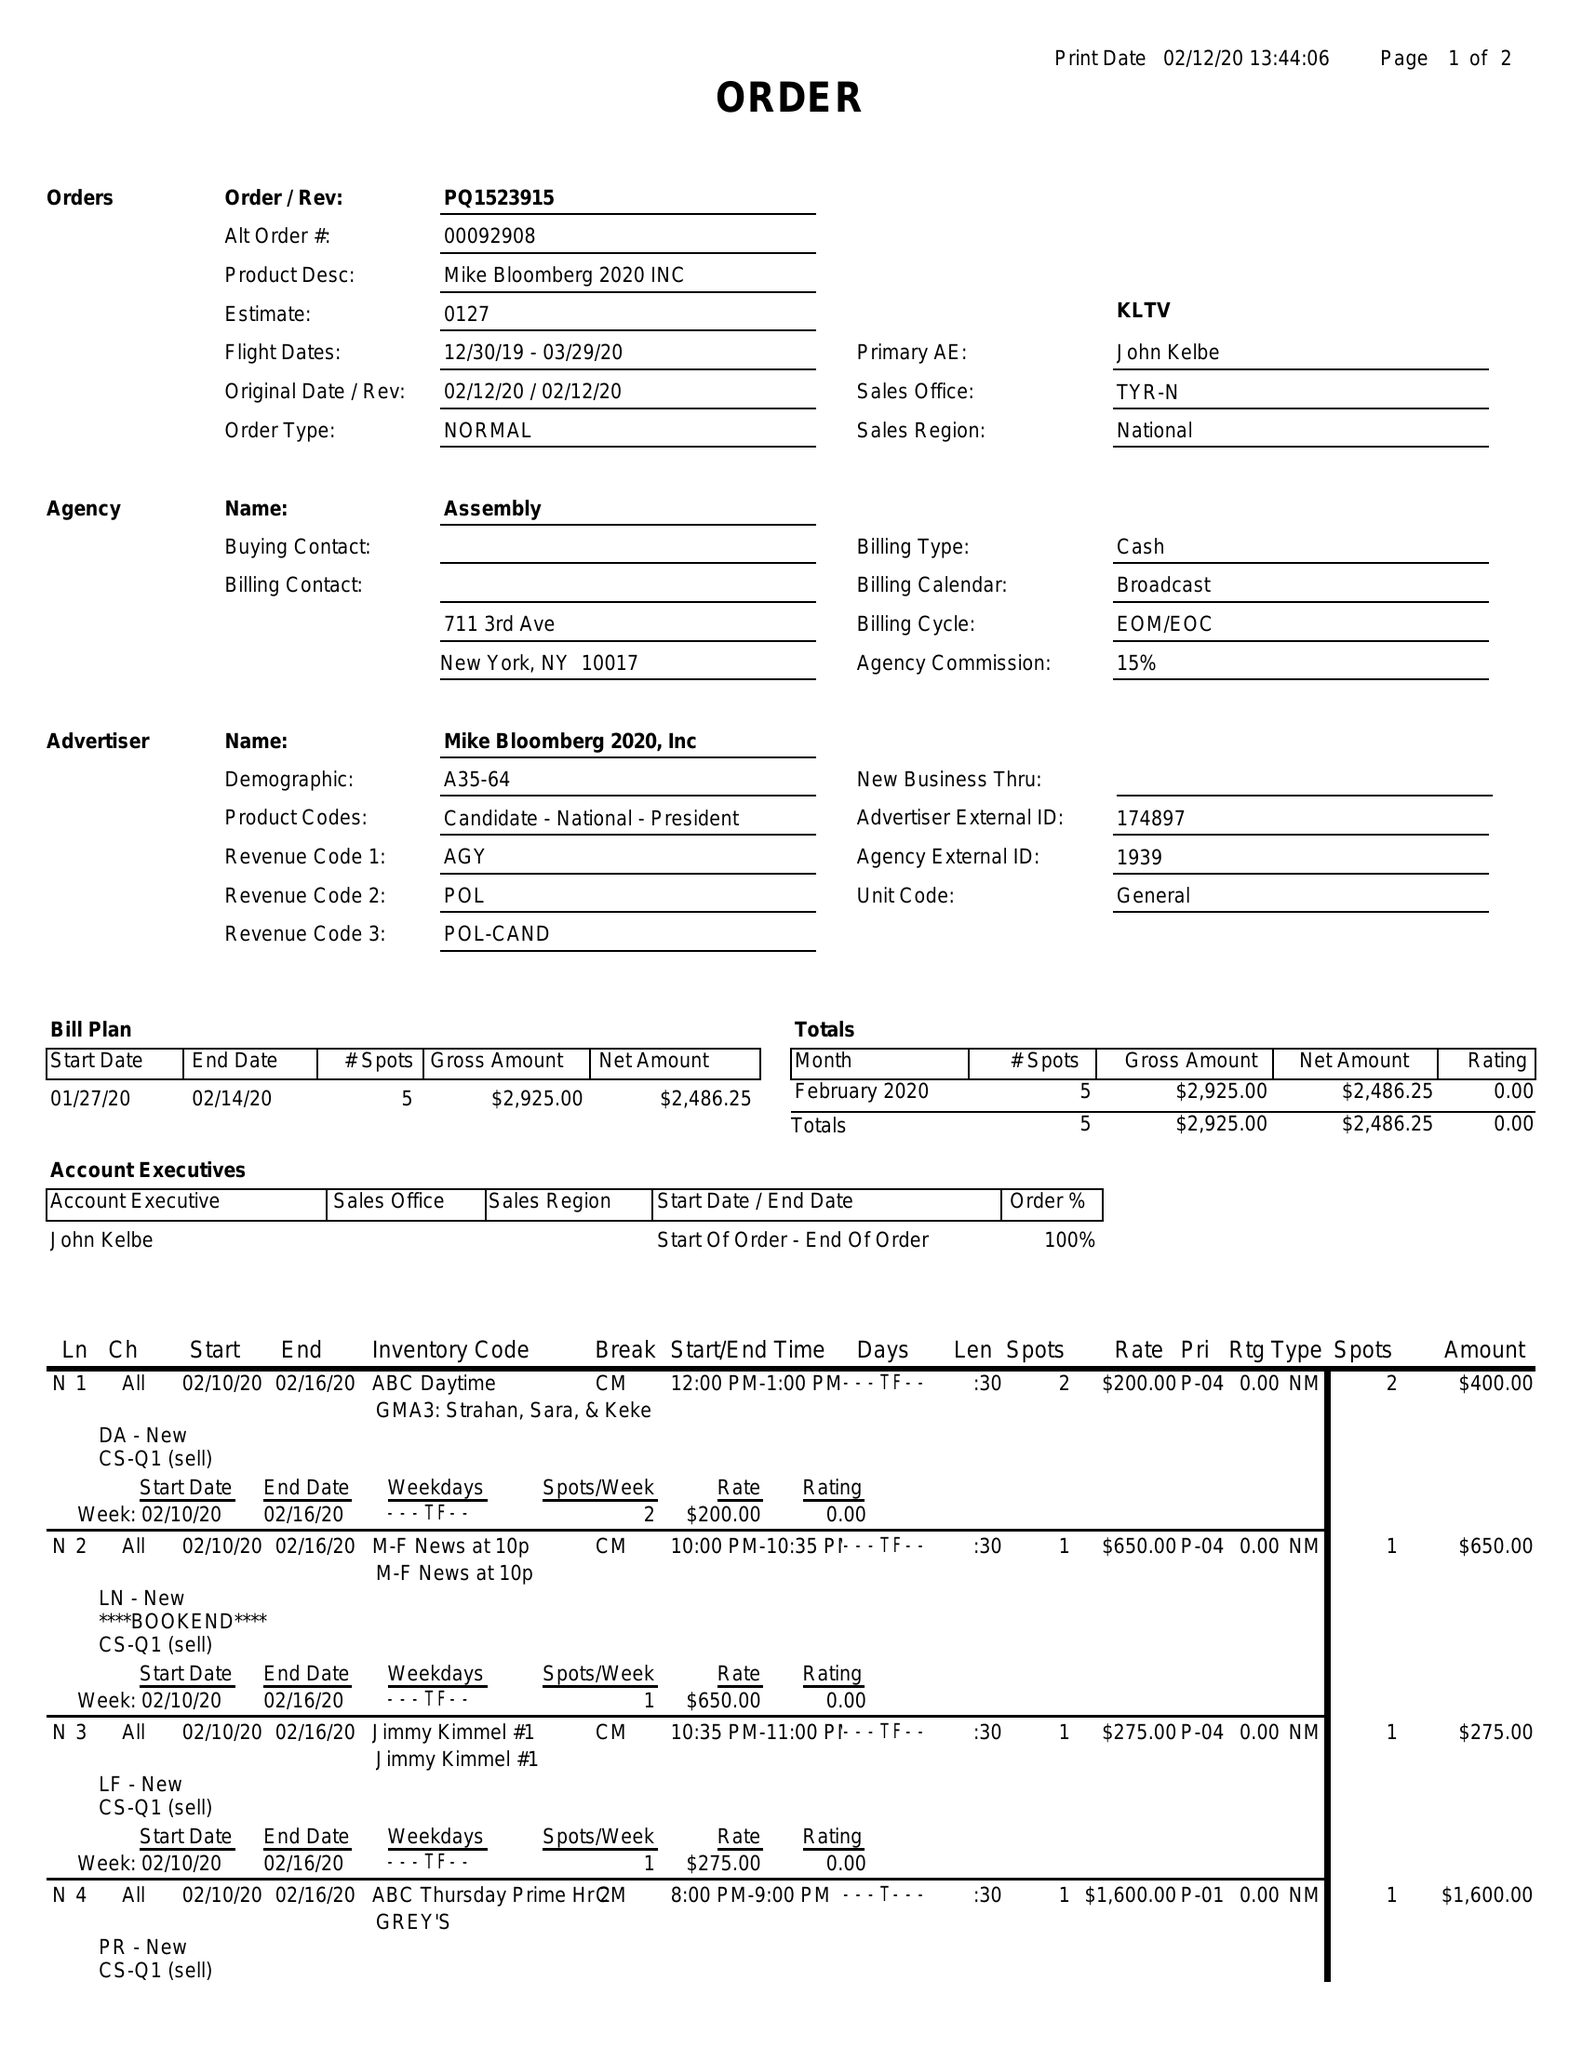What is the value for the flight_from?
Answer the question using a single word or phrase. 12/30/19 